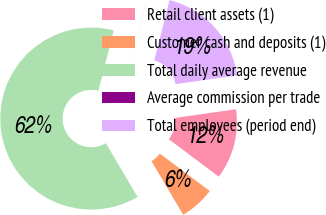Convert chart. <chart><loc_0><loc_0><loc_500><loc_500><pie_chart><fcel>Retail client assets (1)<fcel>Customer cash and deposits (1)<fcel>Total daily average revenue<fcel>Average commission per trade<fcel>Total employees (period end)<nl><fcel>12.5%<fcel>6.26%<fcel>62.48%<fcel>0.01%<fcel>18.75%<nl></chart> 